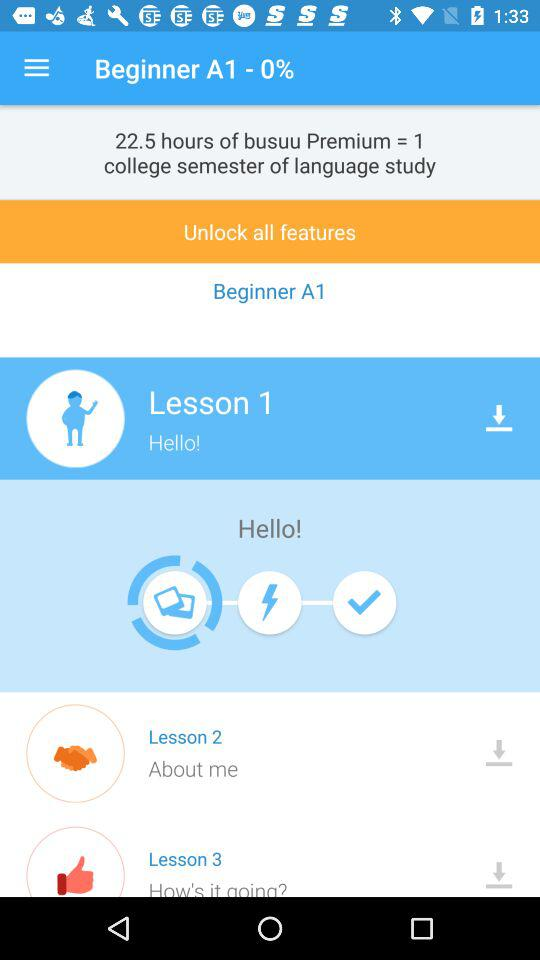How many lessons are there in total?
Answer the question using a single word or phrase. 3 